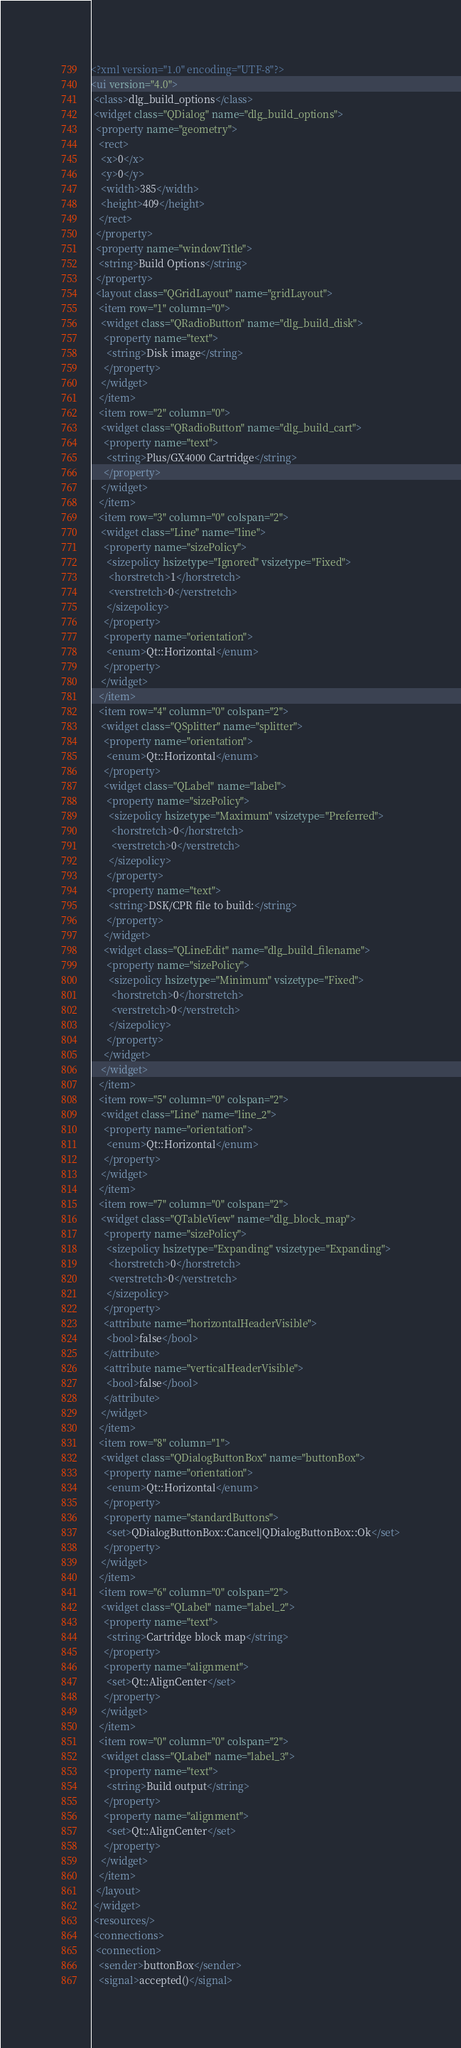<code> <loc_0><loc_0><loc_500><loc_500><_XML_><?xml version="1.0" encoding="UTF-8"?>
<ui version="4.0">
 <class>dlg_build_options</class>
 <widget class="QDialog" name="dlg_build_options">
  <property name="geometry">
   <rect>
    <x>0</x>
    <y>0</y>
    <width>385</width>
    <height>409</height>
   </rect>
  </property>
  <property name="windowTitle">
   <string>Build Options</string>
  </property>
  <layout class="QGridLayout" name="gridLayout">
   <item row="1" column="0">
    <widget class="QRadioButton" name="dlg_build_disk">
     <property name="text">
      <string>Disk image</string>
     </property>
    </widget>
   </item>
   <item row="2" column="0">
    <widget class="QRadioButton" name="dlg_build_cart">
     <property name="text">
      <string>Plus/GX4000 Cartridge</string>
     </property>
    </widget>
   </item>
   <item row="3" column="0" colspan="2">
    <widget class="Line" name="line">
     <property name="sizePolicy">
      <sizepolicy hsizetype="Ignored" vsizetype="Fixed">
       <horstretch>1</horstretch>
       <verstretch>0</verstretch>
      </sizepolicy>
     </property>
     <property name="orientation">
      <enum>Qt::Horizontal</enum>
     </property>
    </widget>
   </item>
   <item row="4" column="0" colspan="2">
    <widget class="QSplitter" name="splitter">
     <property name="orientation">
      <enum>Qt::Horizontal</enum>
     </property>
     <widget class="QLabel" name="label">
      <property name="sizePolicy">
       <sizepolicy hsizetype="Maximum" vsizetype="Preferred">
        <horstretch>0</horstretch>
        <verstretch>0</verstretch>
       </sizepolicy>
      </property>
      <property name="text">
       <string>DSK/CPR file to build:</string>
      </property>
     </widget>
     <widget class="QLineEdit" name="dlg_build_filename">
      <property name="sizePolicy">
       <sizepolicy hsizetype="Minimum" vsizetype="Fixed">
        <horstretch>0</horstretch>
        <verstretch>0</verstretch>
       </sizepolicy>
      </property>
     </widget>
    </widget>
   </item>
   <item row="5" column="0" colspan="2">
    <widget class="Line" name="line_2">
     <property name="orientation">
      <enum>Qt::Horizontal</enum>
     </property>
    </widget>
   </item>
   <item row="7" column="0" colspan="2">
    <widget class="QTableView" name="dlg_block_map">
     <property name="sizePolicy">
      <sizepolicy hsizetype="Expanding" vsizetype="Expanding">
       <horstretch>0</horstretch>
       <verstretch>0</verstretch>
      </sizepolicy>
     </property>
     <attribute name="horizontalHeaderVisible">
      <bool>false</bool>
     </attribute>
     <attribute name="verticalHeaderVisible">
      <bool>false</bool>
     </attribute>
    </widget>
   </item>
   <item row="8" column="1">
    <widget class="QDialogButtonBox" name="buttonBox">
     <property name="orientation">
      <enum>Qt::Horizontal</enum>
     </property>
     <property name="standardButtons">
      <set>QDialogButtonBox::Cancel|QDialogButtonBox::Ok</set>
     </property>
    </widget>
   </item>
   <item row="6" column="0" colspan="2">
    <widget class="QLabel" name="label_2">
     <property name="text">
      <string>Cartridge block map</string>
     </property>
     <property name="alignment">
      <set>Qt::AlignCenter</set>
     </property>
    </widget>
   </item>
   <item row="0" column="0" colspan="2">
    <widget class="QLabel" name="label_3">
     <property name="text">
      <string>Build output</string>
     </property>
     <property name="alignment">
      <set>Qt::AlignCenter</set>
     </property>
    </widget>
   </item>
  </layout>
 </widget>
 <resources/>
 <connections>
  <connection>
   <sender>buttonBox</sender>
   <signal>accepted()</signal></code> 